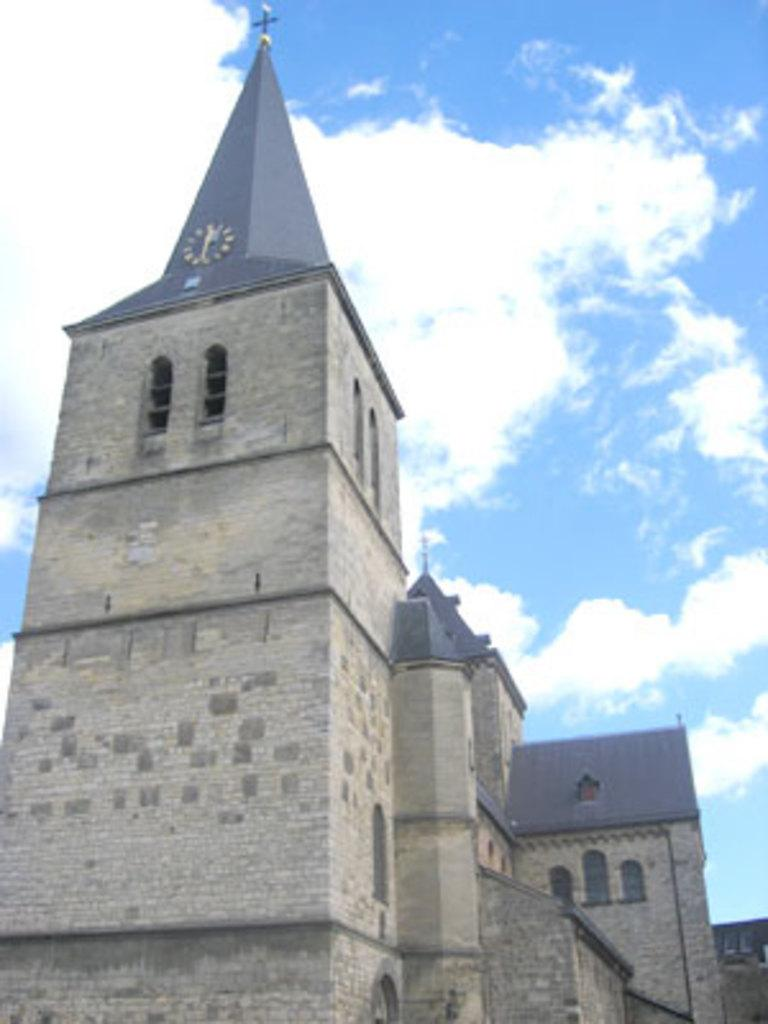What type of structures can be seen in the image? There are buildings in the image. Is there a specific type of building or structure in the image? Yes, there is a clock tower in the image. What can be seen in the background of the image? The sky is visible in the background of the image. What type of crook is visible in the image? There is no crook present in the image. What happens when the clock tower bursts in the image? The clock tower does not burst in the image; it is a stationary structure. 